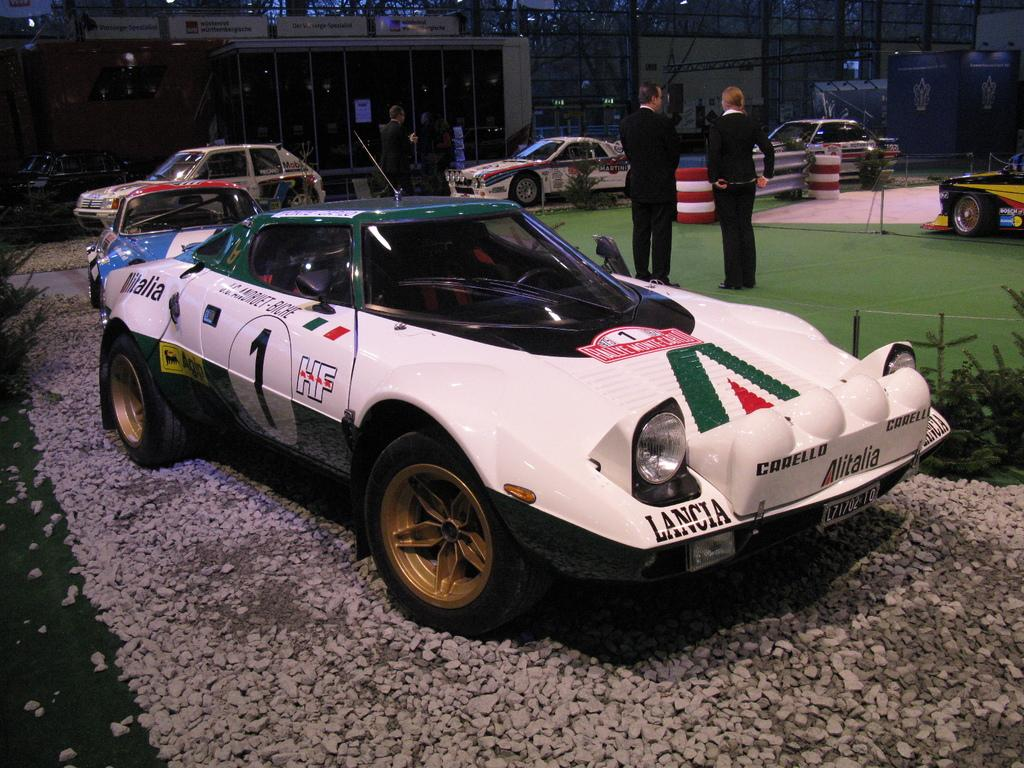What type of vehicles can be seen on the ground in the image? There are cars on the ground in the image. What other objects can be seen in the image besides cars? There are stones, tires, plants, and some unspecified objects in the image. Can you describe the people in the image? Two people are standing in the image. What can be seen in the background of the image? There are name boards, posters, and rods in the background of the image. What type of tooth is visible in the image? There is no tooth present in the image. What sound can be heard coming from the writer in the image? There is no writer or sound present in the image. 